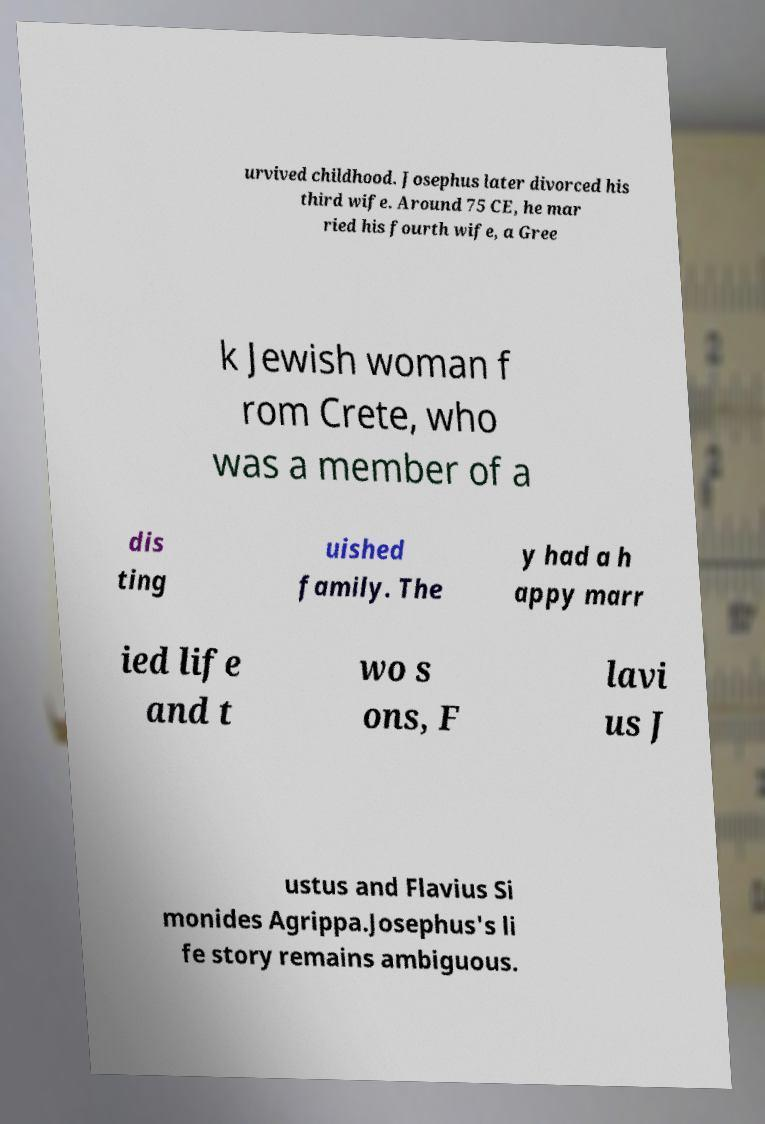Please identify and transcribe the text found in this image. urvived childhood. Josephus later divorced his third wife. Around 75 CE, he mar ried his fourth wife, a Gree k Jewish woman f rom Crete, who was a member of a dis ting uished family. The y had a h appy marr ied life and t wo s ons, F lavi us J ustus and Flavius Si monides Agrippa.Josephus's li fe story remains ambiguous. 